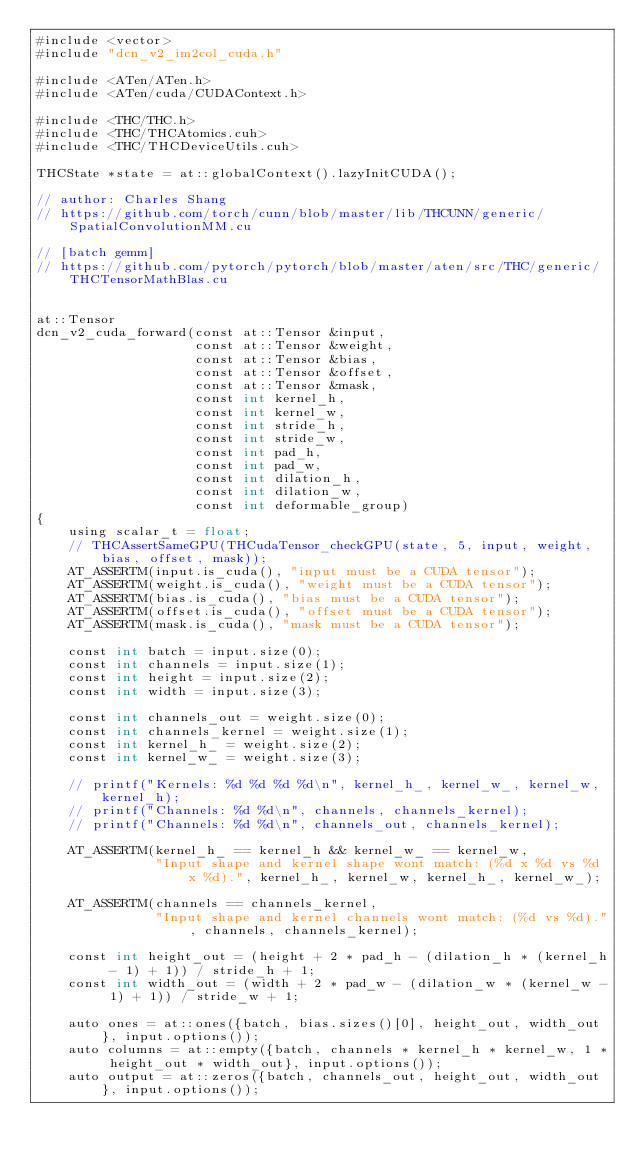Convert code to text. <code><loc_0><loc_0><loc_500><loc_500><_Cuda_>#include <vector>
#include "dcn_v2_im2col_cuda.h"

#include <ATen/ATen.h>
#include <ATen/cuda/CUDAContext.h>

#include <THC/THC.h>
#include <THC/THCAtomics.cuh>
#include <THC/THCDeviceUtils.cuh>

THCState *state = at::globalContext().lazyInitCUDA();

// author: Charles Shang
// https://github.com/torch/cunn/blob/master/lib/THCUNN/generic/SpatialConvolutionMM.cu

// [batch gemm]
// https://github.com/pytorch/pytorch/blob/master/aten/src/THC/generic/THCTensorMathBlas.cu


at::Tensor
dcn_v2_cuda_forward(const at::Tensor &input,
                    const at::Tensor &weight,
                    const at::Tensor &bias,
                    const at::Tensor &offset,
                    const at::Tensor &mask,
                    const int kernel_h,
                    const int kernel_w,
                    const int stride_h,
                    const int stride_w,
                    const int pad_h,
                    const int pad_w,
                    const int dilation_h,
                    const int dilation_w,
                    const int deformable_group)
{
    using scalar_t = float;
    // THCAssertSameGPU(THCudaTensor_checkGPU(state, 5, input, weight, bias, offset, mask));
    AT_ASSERTM(input.is_cuda(), "input must be a CUDA tensor");
    AT_ASSERTM(weight.is_cuda(), "weight must be a CUDA tensor");
    AT_ASSERTM(bias.is_cuda(), "bias must be a CUDA tensor");
    AT_ASSERTM(offset.is_cuda(), "offset must be a CUDA tensor");
    AT_ASSERTM(mask.is_cuda(), "mask must be a CUDA tensor");

    const int batch = input.size(0);
    const int channels = input.size(1);
    const int height = input.size(2);
    const int width = input.size(3);

    const int channels_out = weight.size(0);
    const int channels_kernel = weight.size(1);
    const int kernel_h_ = weight.size(2);
    const int kernel_w_ = weight.size(3);

    // printf("Kernels: %d %d %d %d\n", kernel_h_, kernel_w_, kernel_w, kernel_h);
    // printf("Channels: %d %d\n", channels, channels_kernel);
    // printf("Channels: %d %d\n", channels_out, channels_kernel);

    AT_ASSERTM(kernel_h_ == kernel_h && kernel_w_ == kernel_w,
               "Input shape and kernel shape wont match: (%d x %d vs %d x %d).", kernel_h_, kernel_w, kernel_h_, kernel_w_);

    AT_ASSERTM(channels == channels_kernel,
               "Input shape and kernel channels wont match: (%d vs %d).", channels, channels_kernel);

    const int height_out = (height + 2 * pad_h - (dilation_h * (kernel_h - 1) + 1)) / stride_h + 1;
    const int width_out = (width + 2 * pad_w - (dilation_w * (kernel_w - 1) + 1)) / stride_w + 1;

    auto ones = at::ones({batch, bias.sizes()[0], height_out, width_out}, input.options());
    auto columns = at::empty({batch, channels * kernel_h * kernel_w, 1 * height_out * width_out}, input.options());
    auto output = at::zeros({batch, channels_out, height_out, width_out}, input.options());
</code> 